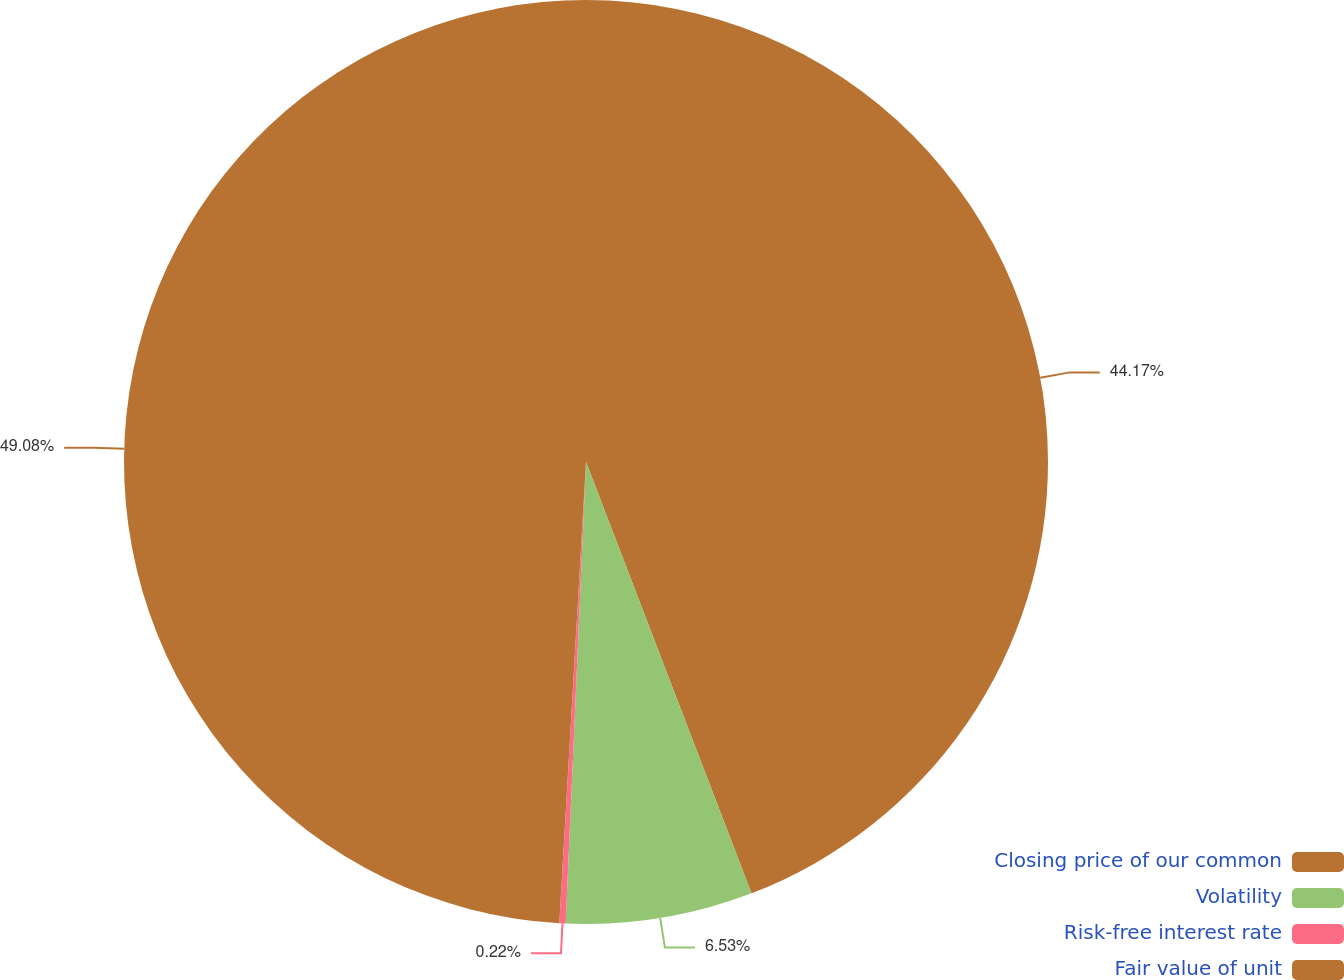Convert chart to OTSL. <chart><loc_0><loc_0><loc_500><loc_500><pie_chart><fcel>Closing price of our common<fcel>Volatility<fcel>Risk-free interest rate<fcel>Fair value of unit<nl><fcel>44.17%<fcel>6.53%<fcel>0.22%<fcel>49.08%<nl></chart> 